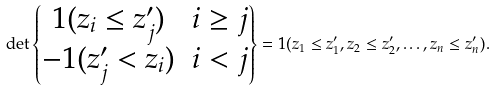Convert formula to latex. <formula><loc_0><loc_0><loc_500><loc_500>\det \begin{Bmatrix} { 1 } ( z _ { i } \leq z ^ { \prime } _ { j } ) & i \geq j \\ - { 1 } ( z ^ { \prime } _ { j } < z _ { i } ) & i < j \end{Bmatrix} = { 1 } ( z _ { 1 } \leq z ^ { \prime } _ { 1 } , z _ { 2 } \leq z ^ { \prime } _ { 2 } , \dots , z _ { n } \leq z ^ { \prime } _ { n } ) .</formula> 